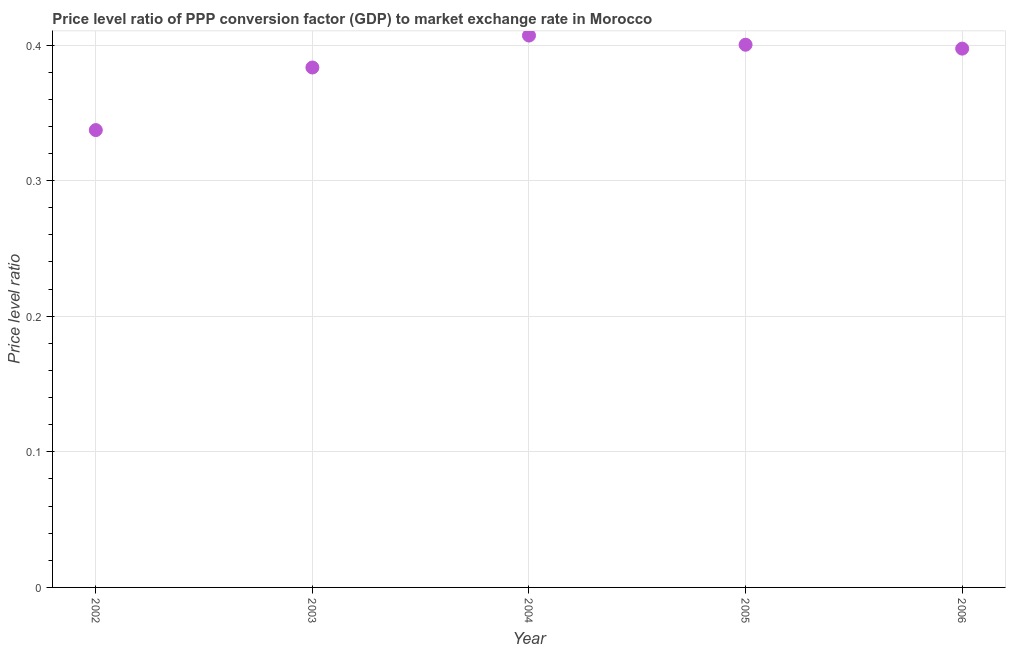What is the price level ratio in 2006?
Provide a short and direct response. 0.4. Across all years, what is the maximum price level ratio?
Your answer should be very brief. 0.41. Across all years, what is the minimum price level ratio?
Keep it short and to the point. 0.34. What is the sum of the price level ratio?
Make the answer very short. 1.93. What is the difference between the price level ratio in 2004 and 2005?
Give a very brief answer. 0.01. What is the average price level ratio per year?
Give a very brief answer. 0.39. What is the median price level ratio?
Keep it short and to the point. 0.4. Do a majority of the years between 2002 and 2006 (inclusive) have price level ratio greater than 0.08 ?
Offer a very short reply. Yes. What is the ratio of the price level ratio in 2002 to that in 2004?
Your answer should be compact. 0.83. Is the difference between the price level ratio in 2003 and 2005 greater than the difference between any two years?
Offer a very short reply. No. What is the difference between the highest and the second highest price level ratio?
Your answer should be compact. 0.01. Is the sum of the price level ratio in 2003 and 2005 greater than the maximum price level ratio across all years?
Make the answer very short. Yes. What is the difference between the highest and the lowest price level ratio?
Your answer should be compact. 0.07. In how many years, is the price level ratio greater than the average price level ratio taken over all years?
Give a very brief answer. 3. Does the price level ratio monotonically increase over the years?
Provide a short and direct response. No. How many dotlines are there?
Provide a short and direct response. 1. How many years are there in the graph?
Keep it short and to the point. 5. What is the difference between two consecutive major ticks on the Y-axis?
Your answer should be compact. 0.1. Are the values on the major ticks of Y-axis written in scientific E-notation?
Offer a terse response. No. What is the title of the graph?
Your answer should be very brief. Price level ratio of PPP conversion factor (GDP) to market exchange rate in Morocco. What is the label or title of the X-axis?
Give a very brief answer. Year. What is the label or title of the Y-axis?
Offer a very short reply. Price level ratio. What is the Price level ratio in 2002?
Your answer should be very brief. 0.34. What is the Price level ratio in 2003?
Make the answer very short. 0.38. What is the Price level ratio in 2004?
Offer a very short reply. 0.41. What is the Price level ratio in 2005?
Give a very brief answer. 0.4. What is the Price level ratio in 2006?
Offer a terse response. 0.4. What is the difference between the Price level ratio in 2002 and 2003?
Give a very brief answer. -0.05. What is the difference between the Price level ratio in 2002 and 2004?
Provide a succinct answer. -0.07. What is the difference between the Price level ratio in 2002 and 2005?
Your response must be concise. -0.06. What is the difference between the Price level ratio in 2002 and 2006?
Offer a terse response. -0.06. What is the difference between the Price level ratio in 2003 and 2004?
Your answer should be very brief. -0.02. What is the difference between the Price level ratio in 2003 and 2005?
Your answer should be very brief. -0.02. What is the difference between the Price level ratio in 2003 and 2006?
Ensure brevity in your answer.  -0.01. What is the difference between the Price level ratio in 2004 and 2005?
Offer a terse response. 0.01. What is the difference between the Price level ratio in 2004 and 2006?
Offer a terse response. 0.01. What is the difference between the Price level ratio in 2005 and 2006?
Provide a short and direct response. 0. What is the ratio of the Price level ratio in 2002 to that in 2003?
Provide a succinct answer. 0.88. What is the ratio of the Price level ratio in 2002 to that in 2004?
Your answer should be very brief. 0.83. What is the ratio of the Price level ratio in 2002 to that in 2005?
Your answer should be very brief. 0.84. What is the ratio of the Price level ratio in 2002 to that in 2006?
Provide a succinct answer. 0.85. What is the ratio of the Price level ratio in 2003 to that in 2004?
Keep it short and to the point. 0.94. What is the ratio of the Price level ratio in 2003 to that in 2005?
Provide a short and direct response. 0.96. What is the ratio of the Price level ratio in 2004 to that in 2005?
Provide a succinct answer. 1.02. What is the ratio of the Price level ratio in 2004 to that in 2006?
Your answer should be compact. 1.02. What is the ratio of the Price level ratio in 2005 to that in 2006?
Offer a terse response. 1.01. 